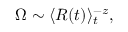<formula> <loc_0><loc_0><loc_500><loc_500>\begin{array} { r } { \Omega \sim \langle R ( t ) \rangle _ { t } ^ { - z } , } \end{array}</formula> 